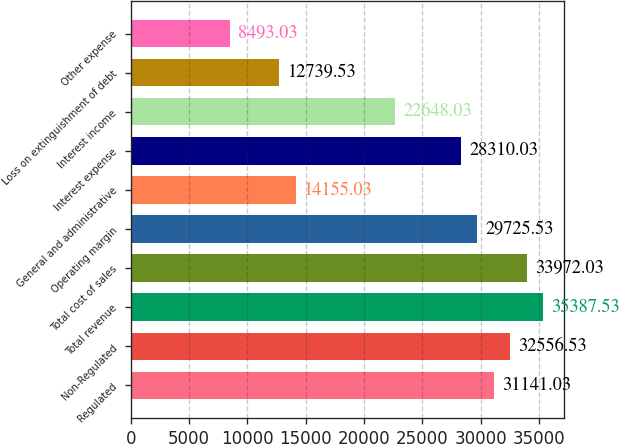<chart> <loc_0><loc_0><loc_500><loc_500><bar_chart><fcel>Regulated<fcel>Non-Regulated<fcel>Total revenue<fcel>Total cost of sales<fcel>Operating margin<fcel>General and administrative<fcel>Interest expense<fcel>Interest income<fcel>Loss on extinguishment of debt<fcel>Other expense<nl><fcel>31141<fcel>32556.5<fcel>35387.5<fcel>33972<fcel>29725.5<fcel>14155<fcel>28310<fcel>22648<fcel>12739.5<fcel>8493.03<nl></chart> 